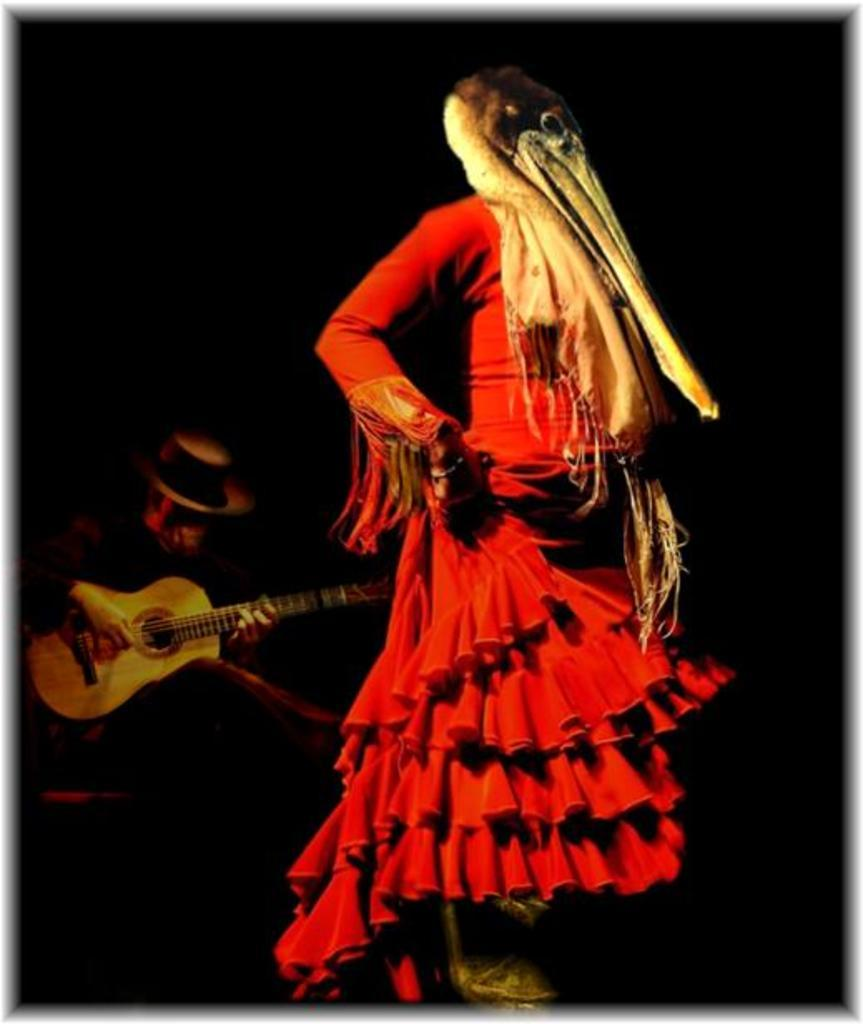What is the person in the image wearing? The person is wearing a red dress in the image. What is covering the person's face? The person is wearing a mask on their face. Can you describe the second person in the image? The second person is sitting on a chair and playing a guitar. What type of pipe can be seen in the person's hand in the image? There is no pipe present in the image; the person is wearing a mask on their face and the second person is playing a guitar. 